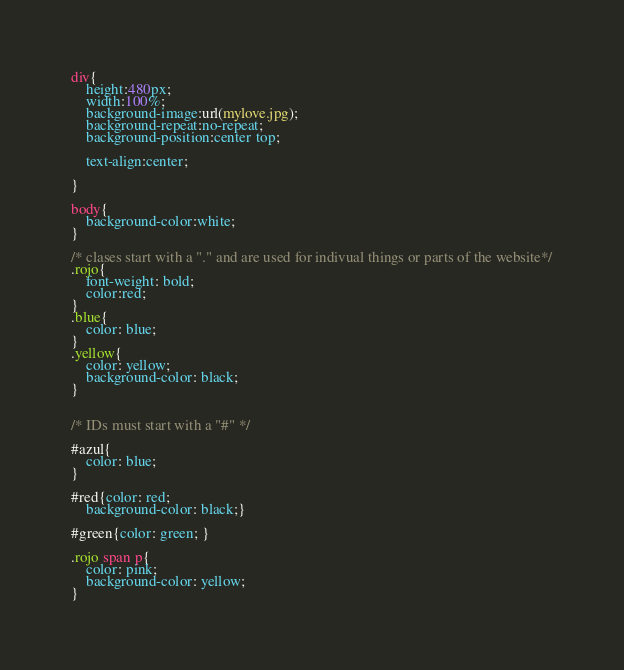Convert code to text. <code><loc_0><loc_0><loc_500><loc_500><_CSS_>div{
	height:480px;
	width:100%;
	background-image:url(mylove.jpg);
	background-repeat:no-repeat;
	background-position:center top;
	
	text-align:center;
	
}

body{
	background-color:white;
}

/* clases start with a "." and are used for indivual things or parts of the website*/
.rojo{
	font-weight: bold;
	color:red;
}
.blue{
	color: blue;
}
.yellow{
	color: yellow;
	background-color: black;
}


/* IDs must start with a "#" */

#azul{
	color: blue;
}

#red{color: red;
	background-color: black;}

#green{color: green; }

.rojo span p{
	color: pink;
	background-color: yellow;
}</code> 